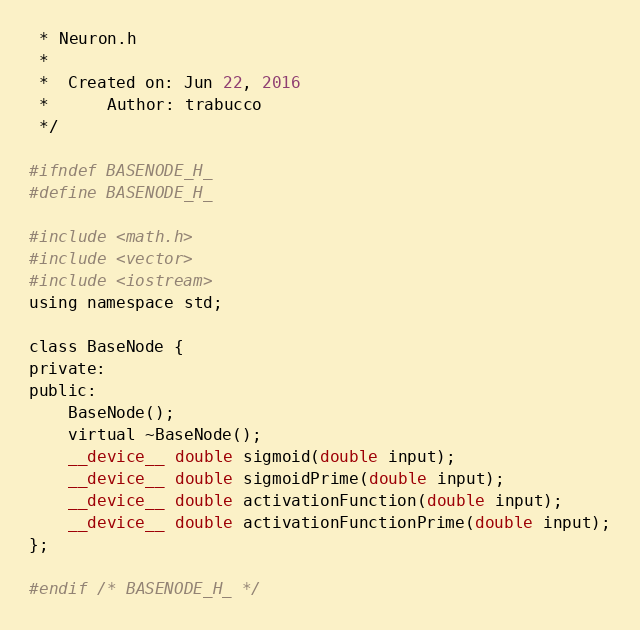<code> <loc_0><loc_0><loc_500><loc_500><_Cuda_> * Neuron.h
 *
 *  Created on: Jun 22, 2016
 *      Author: trabucco
 */

#ifndef BASENODE_H_
#define BASENODE_H_

#include <math.h>
#include <vector>
#include <iostream>
using namespace std;

class BaseNode {
private:
public:
	BaseNode();
	virtual ~BaseNode();
	__device__ double sigmoid(double input);
	__device__ double sigmoidPrime(double input);
	__device__ double activationFunction(double input);
	__device__ double activationFunctionPrime(double input);
};

#endif /* BASENODE_H_ */
</code> 